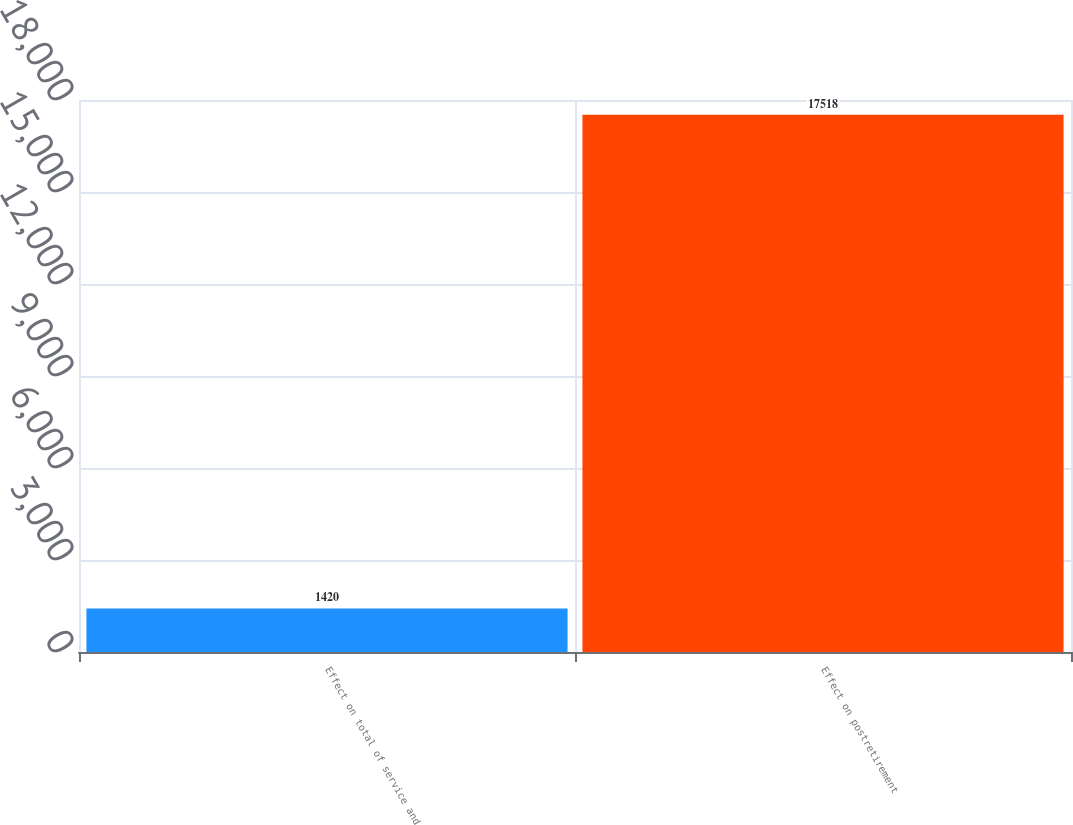Convert chart. <chart><loc_0><loc_0><loc_500><loc_500><bar_chart><fcel>Effect on total of service and<fcel>Effect on postretirement<nl><fcel>1420<fcel>17518<nl></chart> 